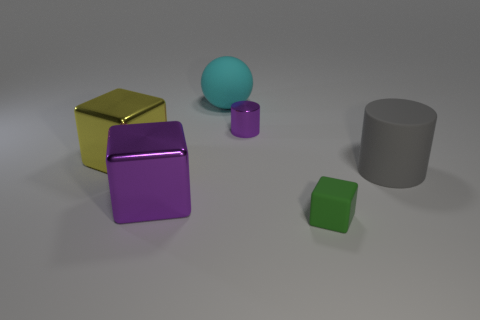Subtract 1 blocks. How many blocks are left? 2 Subtract all big yellow blocks. How many blocks are left? 2 Add 3 gray cylinders. How many objects exist? 9 Subtract all balls. How many objects are left? 5 Subtract all tiny cylinders. Subtract all tiny cyan rubber spheres. How many objects are left? 5 Add 6 large blocks. How many large blocks are left? 8 Add 6 big cylinders. How many big cylinders exist? 7 Subtract 1 green blocks. How many objects are left? 5 